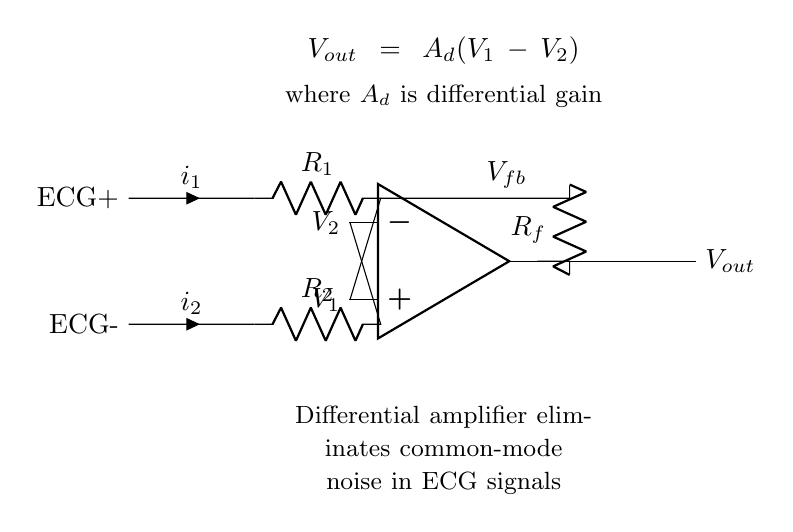What are the two input electrodes labeled in the diagram? The diagram shows two input electrodes, labeled ECG+ and ECG-. These labels identify the positive and negative inputs to the differential amplifier, which are essential for measuring the heart's electrical activity.
Answer: ECG+ and ECG- What does the output voltage represent in this circuit? The output voltage, denoted as Vout, represents the amplified difference between the two input signals (V1 and V2). The differential amplifier's purpose is to provide output proportional to the voltage difference between these two inputs, thus eliminating common-mode noise.
Answer: Vout What is the role of resistor Rf in the circuit? Resistor Rf acts as the feedback resistor in the differential amplifier circuit. Its role is to control the gain of the amplifier, allowing it to effectively amplify the difference between the two input voltages while diminishing common-mode noise.
Answer: Feedback resistor What is the equation representing the output voltage? The equation for the output voltage Vout is given as Vout = Ad(V1 - V2), where Ad denotes the differential gain and (V1 - V2) represents the difference between the input voltages. This equation highlights the fundamental operation of a differential amplifier.
Answer: Vout = Ad(V1 - V2) How do resistors R1 and R2 relate to the common-mode noise? Resistors R1 and R2 are crucial for setting the differential amplifier's input impedance and balancing the circuit. Their configuration helps to minimize the effect of common-mode noise on the ECG signals by ensuring both input signals are processed equally, allowing for effective noise cancellation.
Answer: Minimize noise What is the significance of common-mode rejection in ECG recordings? The significance of common-mode rejection lies in its ability to remove unwanted noise that is present in both input signals (ECG+ and ECG-). This improves the clarity of the ECG recordings, allowing for a more accurate representation of the heart's electrical activity.
Answer: Improve clarity 